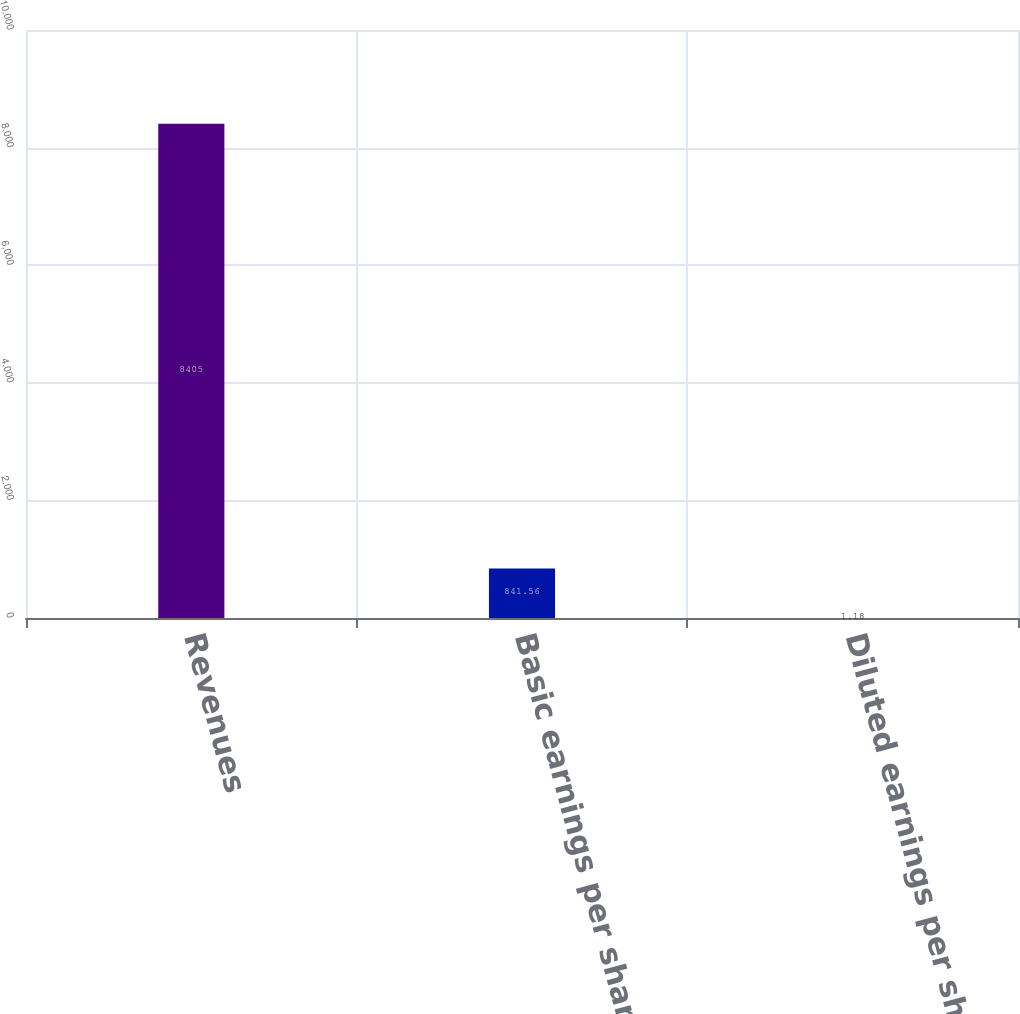Convert chart to OTSL. <chart><loc_0><loc_0><loc_500><loc_500><bar_chart><fcel>Revenues<fcel>Basic earnings per share<fcel>Diluted earnings per share<nl><fcel>8405<fcel>841.56<fcel>1.18<nl></chart> 